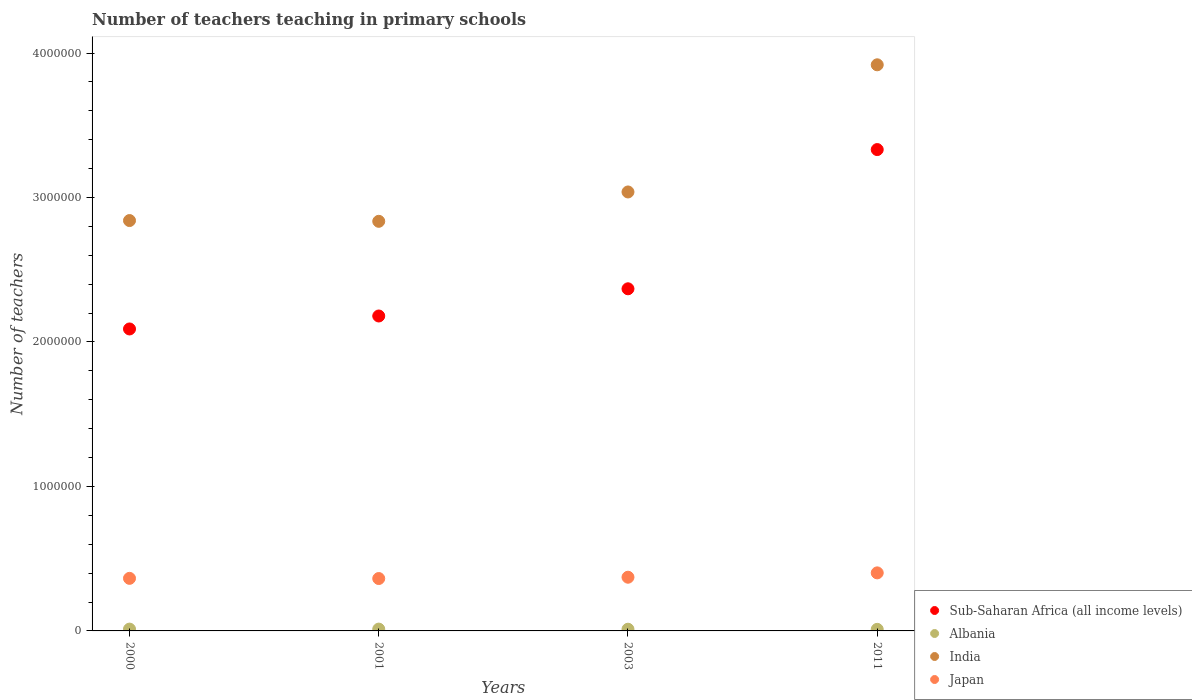How many different coloured dotlines are there?
Ensure brevity in your answer.  4. What is the number of teachers teaching in primary schools in Sub-Saharan Africa (all income levels) in 2001?
Provide a succinct answer. 2.18e+06. Across all years, what is the maximum number of teachers teaching in primary schools in Albania?
Your answer should be very brief. 1.26e+04. Across all years, what is the minimum number of teachers teaching in primary schools in Japan?
Keep it short and to the point. 3.63e+05. What is the total number of teachers teaching in primary schools in Albania in the graph?
Make the answer very short. 4.78e+04. What is the difference between the number of teachers teaching in primary schools in Albania in 2001 and that in 2003?
Your response must be concise. 845. What is the difference between the number of teachers teaching in primary schools in Japan in 2011 and the number of teachers teaching in primary schools in India in 2000?
Offer a terse response. -2.44e+06. What is the average number of teachers teaching in primary schools in Japan per year?
Make the answer very short. 3.75e+05. In the year 2001, what is the difference between the number of teachers teaching in primary schools in Sub-Saharan Africa (all income levels) and number of teachers teaching in primary schools in India?
Provide a succinct answer. -6.55e+05. In how many years, is the number of teachers teaching in primary schools in India greater than 200000?
Give a very brief answer. 4. What is the ratio of the number of teachers teaching in primary schools in Albania in 2000 to that in 2011?
Provide a short and direct response. 1.16. Is the difference between the number of teachers teaching in primary schools in Sub-Saharan Africa (all income levels) in 2000 and 2001 greater than the difference between the number of teachers teaching in primary schools in India in 2000 and 2001?
Provide a succinct answer. No. What is the difference between the highest and the second highest number of teachers teaching in primary schools in Sub-Saharan Africa (all income levels)?
Make the answer very short. 9.64e+05. What is the difference between the highest and the lowest number of teachers teaching in primary schools in Albania?
Provide a succinct answer. 1753. In how many years, is the number of teachers teaching in primary schools in Albania greater than the average number of teachers teaching in primary schools in Albania taken over all years?
Offer a terse response. 2. Is it the case that in every year, the sum of the number of teachers teaching in primary schools in Japan and number of teachers teaching in primary schools in Albania  is greater than the sum of number of teachers teaching in primary schools in Sub-Saharan Africa (all income levels) and number of teachers teaching in primary schools in India?
Offer a terse response. No. Does the number of teachers teaching in primary schools in Sub-Saharan Africa (all income levels) monotonically increase over the years?
Your answer should be very brief. Yes. Is the number of teachers teaching in primary schools in Japan strictly greater than the number of teachers teaching in primary schools in Sub-Saharan Africa (all income levels) over the years?
Offer a very short reply. No. How many dotlines are there?
Offer a terse response. 4. What is the difference between two consecutive major ticks on the Y-axis?
Your answer should be very brief. 1.00e+06. Does the graph contain any zero values?
Provide a short and direct response. No. Does the graph contain grids?
Give a very brief answer. No. What is the title of the graph?
Give a very brief answer. Number of teachers teaching in primary schools. Does "Malawi" appear as one of the legend labels in the graph?
Provide a short and direct response. No. What is the label or title of the X-axis?
Give a very brief answer. Years. What is the label or title of the Y-axis?
Provide a short and direct response. Number of teachers. What is the Number of teachers of Sub-Saharan Africa (all income levels) in 2000?
Give a very brief answer. 2.09e+06. What is the Number of teachers of Albania in 2000?
Provide a succinct answer. 1.26e+04. What is the Number of teachers of India in 2000?
Provide a short and direct response. 2.84e+06. What is the Number of teachers of Japan in 2000?
Make the answer very short. 3.64e+05. What is the Number of teachers of Sub-Saharan Africa (all income levels) in 2001?
Offer a terse response. 2.18e+06. What is the Number of teachers in Albania in 2001?
Your answer should be very brief. 1.26e+04. What is the Number of teachers in India in 2001?
Make the answer very short. 2.84e+06. What is the Number of teachers of Japan in 2001?
Offer a very short reply. 3.63e+05. What is the Number of teachers in Sub-Saharan Africa (all income levels) in 2003?
Your answer should be compact. 2.37e+06. What is the Number of teachers in Albania in 2003?
Provide a succinct answer. 1.18e+04. What is the Number of teachers in India in 2003?
Your answer should be compact. 3.04e+06. What is the Number of teachers of Japan in 2003?
Keep it short and to the point. 3.72e+05. What is the Number of teachers in Sub-Saharan Africa (all income levels) in 2011?
Your answer should be very brief. 3.33e+06. What is the Number of teachers in Albania in 2011?
Provide a short and direct response. 1.09e+04. What is the Number of teachers of India in 2011?
Provide a short and direct response. 3.92e+06. What is the Number of teachers in Japan in 2011?
Your answer should be very brief. 4.02e+05. Across all years, what is the maximum Number of teachers of Sub-Saharan Africa (all income levels)?
Give a very brief answer. 3.33e+06. Across all years, what is the maximum Number of teachers of Albania?
Offer a very short reply. 1.26e+04. Across all years, what is the maximum Number of teachers in India?
Your response must be concise. 3.92e+06. Across all years, what is the maximum Number of teachers in Japan?
Ensure brevity in your answer.  4.02e+05. Across all years, what is the minimum Number of teachers of Sub-Saharan Africa (all income levels)?
Keep it short and to the point. 2.09e+06. Across all years, what is the minimum Number of teachers in Albania?
Offer a very short reply. 1.09e+04. Across all years, what is the minimum Number of teachers in India?
Ensure brevity in your answer.  2.84e+06. Across all years, what is the minimum Number of teachers in Japan?
Keep it short and to the point. 3.63e+05. What is the total Number of teachers in Sub-Saharan Africa (all income levels) in the graph?
Your answer should be compact. 9.97e+06. What is the total Number of teachers in Albania in the graph?
Your response must be concise. 4.78e+04. What is the total Number of teachers of India in the graph?
Your answer should be compact. 1.26e+07. What is the total Number of teachers in Japan in the graph?
Offer a terse response. 1.50e+06. What is the difference between the Number of teachers in Sub-Saharan Africa (all income levels) in 2000 and that in 2001?
Give a very brief answer. -8.97e+04. What is the difference between the Number of teachers of Albania in 2000 and that in 2001?
Provide a short and direct response. -56. What is the difference between the Number of teachers of India in 2000 and that in 2001?
Make the answer very short. 5270. What is the difference between the Number of teachers of Japan in 2000 and that in 2001?
Provide a succinct answer. 1275. What is the difference between the Number of teachers of Sub-Saharan Africa (all income levels) in 2000 and that in 2003?
Offer a very short reply. -2.78e+05. What is the difference between the Number of teachers in Albania in 2000 and that in 2003?
Ensure brevity in your answer.  789. What is the difference between the Number of teachers in India in 2000 and that in 2003?
Give a very brief answer. -1.98e+05. What is the difference between the Number of teachers in Japan in 2000 and that in 2003?
Make the answer very short. -7808. What is the difference between the Number of teachers in Sub-Saharan Africa (all income levels) in 2000 and that in 2011?
Make the answer very short. -1.24e+06. What is the difference between the Number of teachers of Albania in 2000 and that in 2011?
Provide a short and direct response. 1697. What is the difference between the Number of teachers in India in 2000 and that in 2011?
Keep it short and to the point. -1.08e+06. What is the difference between the Number of teachers of Japan in 2000 and that in 2011?
Offer a very short reply. -3.79e+04. What is the difference between the Number of teachers in Sub-Saharan Africa (all income levels) in 2001 and that in 2003?
Provide a succinct answer. -1.88e+05. What is the difference between the Number of teachers in Albania in 2001 and that in 2003?
Your response must be concise. 845. What is the difference between the Number of teachers of India in 2001 and that in 2003?
Provide a short and direct response. -2.03e+05. What is the difference between the Number of teachers of Japan in 2001 and that in 2003?
Provide a succinct answer. -9083. What is the difference between the Number of teachers of Sub-Saharan Africa (all income levels) in 2001 and that in 2011?
Make the answer very short. -1.15e+06. What is the difference between the Number of teachers in Albania in 2001 and that in 2011?
Your answer should be compact. 1753. What is the difference between the Number of teachers of India in 2001 and that in 2011?
Provide a short and direct response. -1.08e+06. What is the difference between the Number of teachers in Japan in 2001 and that in 2011?
Provide a short and direct response. -3.92e+04. What is the difference between the Number of teachers of Sub-Saharan Africa (all income levels) in 2003 and that in 2011?
Keep it short and to the point. -9.64e+05. What is the difference between the Number of teachers in Albania in 2003 and that in 2011?
Offer a terse response. 908. What is the difference between the Number of teachers of India in 2003 and that in 2011?
Give a very brief answer. -8.80e+05. What is the difference between the Number of teachers in Japan in 2003 and that in 2011?
Keep it short and to the point. -3.01e+04. What is the difference between the Number of teachers of Sub-Saharan Africa (all income levels) in 2000 and the Number of teachers of Albania in 2001?
Make the answer very short. 2.08e+06. What is the difference between the Number of teachers of Sub-Saharan Africa (all income levels) in 2000 and the Number of teachers of India in 2001?
Offer a very short reply. -7.45e+05. What is the difference between the Number of teachers in Sub-Saharan Africa (all income levels) in 2000 and the Number of teachers in Japan in 2001?
Give a very brief answer. 1.73e+06. What is the difference between the Number of teachers in Albania in 2000 and the Number of teachers in India in 2001?
Ensure brevity in your answer.  -2.82e+06. What is the difference between the Number of teachers of Albania in 2000 and the Number of teachers of Japan in 2001?
Offer a very short reply. -3.50e+05. What is the difference between the Number of teachers in India in 2000 and the Number of teachers in Japan in 2001?
Offer a terse response. 2.48e+06. What is the difference between the Number of teachers of Sub-Saharan Africa (all income levels) in 2000 and the Number of teachers of Albania in 2003?
Your answer should be compact. 2.08e+06. What is the difference between the Number of teachers of Sub-Saharan Africa (all income levels) in 2000 and the Number of teachers of India in 2003?
Your answer should be compact. -9.48e+05. What is the difference between the Number of teachers in Sub-Saharan Africa (all income levels) in 2000 and the Number of teachers in Japan in 2003?
Offer a very short reply. 1.72e+06. What is the difference between the Number of teachers of Albania in 2000 and the Number of teachers of India in 2003?
Give a very brief answer. -3.03e+06. What is the difference between the Number of teachers of Albania in 2000 and the Number of teachers of Japan in 2003?
Your answer should be compact. -3.59e+05. What is the difference between the Number of teachers of India in 2000 and the Number of teachers of Japan in 2003?
Ensure brevity in your answer.  2.47e+06. What is the difference between the Number of teachers of Sub-Saharan Africa (all income levels) in 2000 and the Number of teachers of Albania in 2011?
Your response must be concise. 2.08e+06. What is the difference between the Number of teachers of Sub-Saharan Africa (all income levels) in 2000 and the Number of teachers of India in 2011?
Your answer should be very brief. -1.83e+06. What is the difference between the Number of teachers of Sub-Saharan Africa (all income levels) in 2000 and the Number of teachers of Japan in 2011?
Keep it short and to the point. 1.69e+06. What is the difference between the Number of teachers of Albania in 2000 and the Number of teachers of India in 2011?
Your answer should be compact. -3.91e+06. What is the difference between the Number of teachers in Albania in 2000 and the Number of teachers in Japan in 2011?
Make the answer very short. -3.89e+05. What is the difference between the Number of teachers of India in 2000 and the Number of teachers of Japan in 2011?
Make the answer very short. 2.44e+06. What is the difference between the Number of teachers in Sub-Saharan Africa (all income levels) in 2001 and the Number of teachers in Albania in 2003?
Offer a very short reply. 2.17e+06. What is the difference between the Number of teachers of Sub-Saharan Africa (all income levels) in 2001 and the Number of teachers of India in 2003?
Your answer should be very brief. -8.58e+05. What is the difference between the Number of teachers of Sub-Saharan Africa (all income levels) in 2001 and the Number of teachers of Japan in 2003?
Your answer should be very brief. 1.81e+06. What is the difference between the Number of teachers of Albania in 2001 and the Number of teachers of India in 2003?
Your answer should be compact. -3.03e+06. What is the difference between the Number of teachers in Albania in 2001 and the Number of teachers in Japan in 2003?
Keep it short and to the point. -3.59e+05. What is the difference between the Number of teachers of India in 2001 and the Number of teachers of Japan in 2003?
Provide a succinct answer. 2.46e+06. What is the difference between the Number of teachers in Sub-Saharan Africa (all income levels) in 2001 and the Number of teachers in Albania in 2011?
Provide a short and direct response. 2.17e+06. What is the difference between the Number of teachers of Sub-Saharan Africa (all income levels) in 2001 and the Number of teachers of India in 2011?
Make the answer very short. -1.74e+06. What is the difference between the Number of teachers in Sub-Saharan Africa (all income levels) in 2001 and the Number of teachers in Japan in 2011?
Keep it short and to the point. 1.78e+06. What is the difference between the Number of teachers in Albania in 2001 and the Number of teachers in India in 2011?
Keep it short and to the point. -3.91e+06. What is the difference between the Number of teachers in Albania in 2001 and the Number of teachers in Japan in 2011?
Provide a succinct answer. -3.89e+05. What is the difference between the Number of teachers of India in 2001 and the Number of teachers of Japan in 2011?
Offer a terse response. 2.43e+06. What is the difference between the Number of teachers of Sub-Saharan Africa (all income levels) in 2003 and the Number of teachers of Albania in 2011?
Your answer should be very brief. 2.36e+06. What is the difference between the Number of teachers of Sub-Saharan Africa (all income levels) in 2003 and the Number of teachers of India in 2011?
Your answer should be very brief. -1.55e+06. What is the difference between the Number of teachers of Sub-Saharan Africa (all income levels) in 2003 and the Number of teachers of Japan in 2011?
Your answer should be very brief. 1.97e+06. What is the difference between the Number of teachers in Albania in 2003 and the Number of teachers in India in 2011?
Your answer should be compact. -3.91e+06. What is the difference between the Number of teachers of Albania in 2003 and the Number of teachers of Japan in 2011?
Make the answer very short. -3.90e+05. What is the difference between the Number of teachers in India in 2003 and the Number of teachers in Japan in 2011?
Make the answer very short. 2.64e+06. What is the average Number of teachers of Sub-Saharan Africa (all income levels) per year?
Make the answer very short. 2.49e+06. What is the average Number of teachers of Albania per year?
Keep it short and to the point. 1.19e+04. What is the average Number of teachers of India per year?
Give a very brief answer. 3.16e+06. What is the average Number of teachers in Japan per year?
Your answer should be compact. 3.75e+05. In the year 2000, what is the difference between the Number of teachers of Sub-Saharan Africa (all income levels) and Number of teachers of Albania?
Give a very brief answer. 2.08e+06. In the year 2000, what is the difference between the Number of teachers in Sub-Saharan Africa (all income levels) and Number of teachers in India?
Make the answer very short. -7.50e+05. In the year 2000, what is the difference between the Number of teachers of Sub-Saharan Africa (all income levels) and Number of teachers of Japan?
Your response must be concise. 1.73e+06. In the year 2000, what is the difference between the Number of teachers in Albania and Number of teachers in India?
Keep it short and to the point. -2.83e+06. In the year 2000, what is the difference between the Number of teachers of Albania and Number of teachers of Japan?
Provide a short and direct response. -3.51e+05. In the year 2000, what is the difference between the Number of teachers of India and Number of teachers of Japan?
Offer a very short reply. 2.48e+06. In the year 2001, what is the difference between the Number of teachers of Sub-Saharan Africa (all income levels) and Number of teachers of Albania?
Offer a very short reply. 2.17e+06. In the year 2001, what is the difference between the Number of teachers of Sub-Saharan Africa (all income levels) and Number of teachers of India?
Offer a terse response. -6.55e+05. In the year 2001, what is the difference between the Number of teachers of Sub-Saharan Africa (all income levels) and Number of teachers of Japan?
Give a very brief answer. 1.82e+06. In the year 2001, what is the difference between the Number of teachers in Albania and Number of teachers in India?
Your response must be concise. -2.82e+06. In the year 2001, what is the difference between the Number of teachers in Albania and Number of teachers in Japan?
Offer a very short reply. -3.50e+05. In the year 2001, what is the difference between the Number of teachers in India and Number of teachers in Japan?
Your response must be concise. 2.47e+06. In the year 2003, what is the difference between the Number of teachers in Sub-Saharan Africa (all income levels) and Number of teachers in Albania?
Your answer should be very brief. 2.36e+06. In the year 2003, what is the difference between the Number of teachers in Sub-Saharan Africa (all income levels) and Number of teachers in India?
Your answer should be very brief. -6.70e+05. In the year 2003, what is the difference between the Number of teachers in Sub-Saharan Africa (all income levels) and Number of teachers in Japan?
Keep it short and to the point. 2.00e+06. In the year 2003, what is the difference between the Number of teachers of Albania and Number of teachers of India?
Offer a very short reply. -3.03e+06. In the year 2003, what is the difference between the Number of teachers in Albania and Number of teachers in Japan?
Provide a short and direct response. -3.60e+05. In the year 2003, what is the difference between the Number of teachers of India and Number of teachers of Japan?
Your answer should be very brief. 2.67e+06. In the year 2011, what is the difference between the Number of teachers in Sub-Saharan Africa (all income levels) and Number of teachers in Albania?
Keep it short and to the point. 3.32e+06. In the year 2011, what is the difference between the Number of teachers of Sub-Saharan Africa (all income levels) and Number of teachers of India?
Ensure brevity in your answer.  -5.87e+05. In the year 2011, what is the difference between the Number of teachers in Sub-Saharan Africa (all income levels) and Number of teachers in Japan?
Make the answer very short. 2.93e+06. In the year 2011, what is the difference between the Number of teachers of Albania and Number of teachers of India?
Provide a succinct answer. -3.91e+06. In the year 2011, what is the difference between the Number of teachers of Albania and Number of teachers of Japan?
Offer a very short reply. -3.91e+05. In the year 2011, what is the difference between the Number of teachers of India and Number of teachers of Japan?
Your answer should be very brief. 3.52e+06. What is the ratio of the Number of teachers of Sub-Saharan Africa (all income levels) in 2000 to that in 2001?
Your response must be concise. 0.96. What is the ratio of the Number of teachers of Sub-Saharan Africa (all income levels) in 2000 to that in 2003?
Ensure brevity in your answer.  0.88. What is the ratio of the Number of teachers in Albania in 2000 to that in 2003?
Make the answer very short. 1.07. What is the ratio of the Number of teachers of India in 2000 to that in 2003?
Provide a short and direct response. 0.93. What is the ratio of the Number of teachers in Sub-Saharan Africa (all income levels) in 2000 to that in 2011?
Your answer should be compact. 0.63. What is the ratio of the Number of teachers of Albania in 2000 to that in 2011?
Give a very brief answer. 1.16. What is the ratio of the Number of teachers of India in 2000 to that in 2011?
Offer a terse response. 0.72. What is the ratio of the Number of teachers of Japan in 2000 to that in 2011?
Give a very brief answer. 0.91. What is the ratio of the Number of teachers of Sub-Saharan Africa (all income levels) in 2001 to that in 2003?
Your response must be concise. 0.92. What is the ratio of the Number of teachers in Albania in 2001 to that in 2003?
Offer a terse response. 1.07. What is the ratio of the Number of teachers in India in 2001 to that in 2003?
Ensure brevity in your answer.  0.93. What is the ratio of the Number of teachers of Japan in 2001 to that in 2003?
Your response must be concise. 0.98. What is the ratio of the Number of teachers in Sub-Saharan Africa (all income levels) in 2001 to that in 2011?
Your response must be concise. 0.65. What is the ratio of the Number of teachers in Albania in 2001 to that in 2011?
Ensure brevity in your answer.  1.16. What is the ratio of the Number of teachers in India in 2001 to that in 2011?
Provide a succinct answer. 0.72. What is the ratio of the Number of teachers in Japan in 2001 to that in 2011?
Provide a succinct answer. 0.9. What is the ratio of the Number of teachers of Sub-Saharan Africa (all income levels) in 2003 to that in 2011?
Your response must be concise. 0.71. What is the ratio of the Number of teachers of Albania in 2003 to that in 2011?
Your answer should be very brief. 1.08. What is the ratio of the Number of teachers in India in 2003 to that in 2011?
Offer a very short reply. 0.78. What is the ratio of the Number of teachers of Japan in 2003 to that in 2011?
Provide a succinct answer. 0.93. What is the difference between the highest and the second highest Number of teachers of Sub-Saharan Africa (all income levels)?
Offer a terse response. 9.64e+05. What is the difference between the highest and the second highest Number of teachers of Albania?
Make the answer very short. 56. What is the difference between the highest and the second highest Number of teachers of India?
Your answer should be very brief. 8.80e+05. What is the difference between the highest and the second highest Number of teachers of Japan?
Keep it short and to the point. 3.01e+04. What is the difference between the highest and the lowest Number of teachers of Sub-Saharan Africa (all income levels)?
Give a very brief answer. 1.24e+06. What is the difference between the highest and the lowest Number of teachers of Albania?
Your answer should be compact. 1753. What is the difference between the highest and the lowest Number of teachers of India?
Offer a terse response. 1.08e+06. What is the difference between the highest and the lowest Number of teachers in Japan?
Keep it short and to the point. 3.92e+04. 